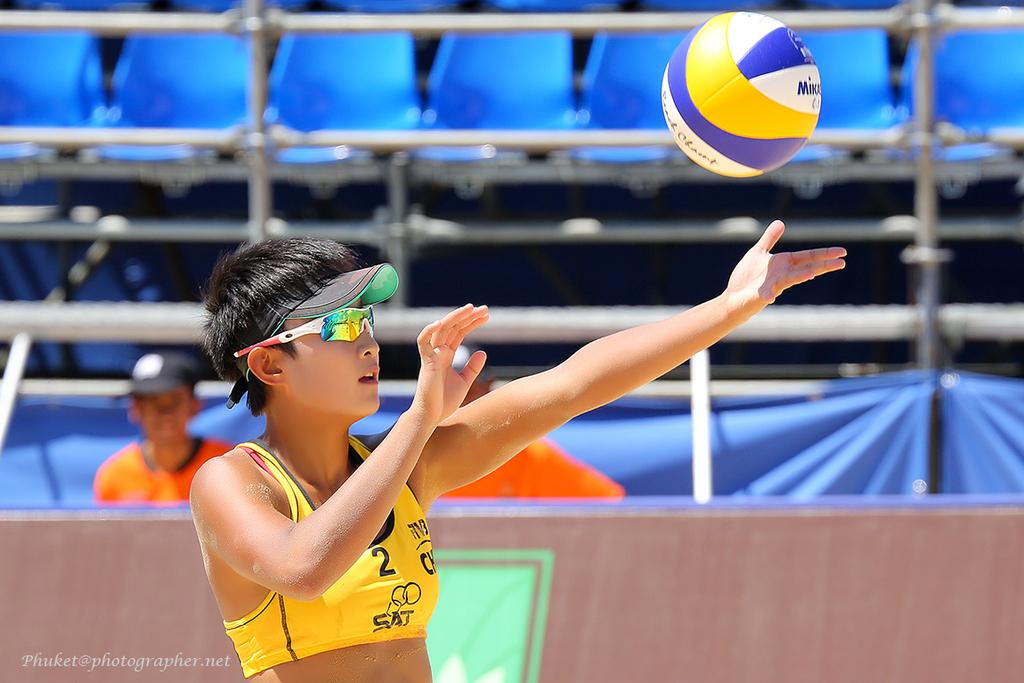<image>
Relay a brief, clear account of the picture shown. A woman wearing a yellow top with the number 2 on it is about to recieve a ball. 